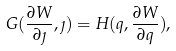<formula> <loc_0><loc_0><loc_500><loc_500>G ( \frac { \partial W } { \partial \eta } , \eta ) = H ( q , \frac { \partial W } { \partial q } ) ,</formula> 